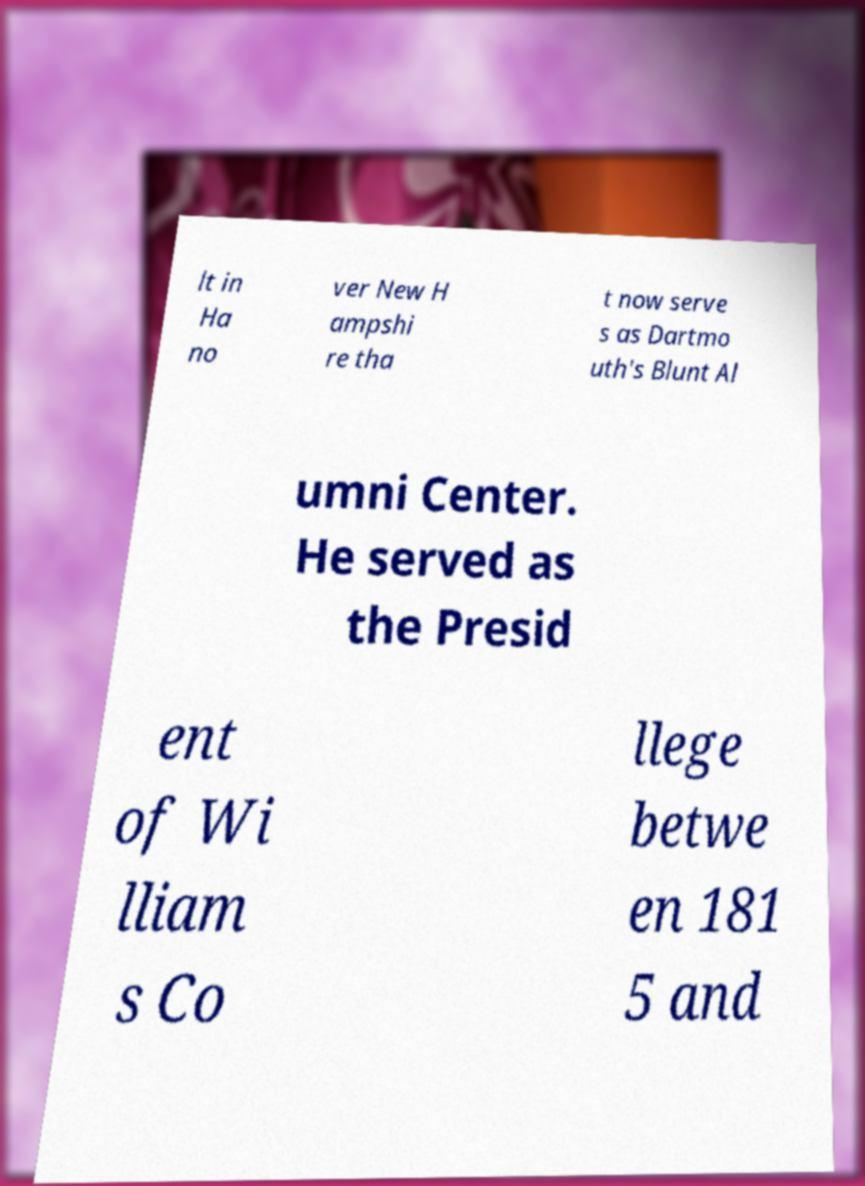Could you assist in decoding the text presented in this image and type it out clearly? lt in Ha no ver New H ampshi re tha t now serve s as Dartmo uth's Blunt Al umni Center. He served as the Presid ent of Wi lliam s Co llege betwe en 181 5 and 